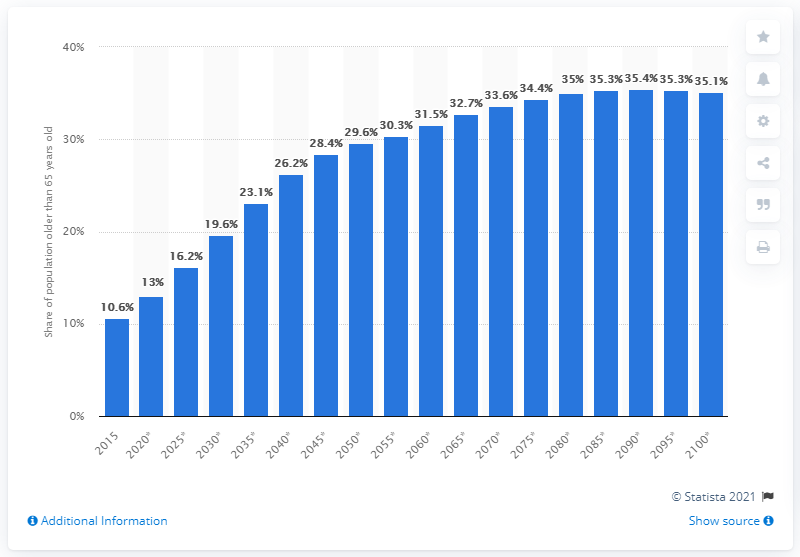Highlight a few significant elements in this photo. In 2015, approximately 10.6% of the population in Thailand was older than 65 years old. According to projections, by the year 2100, it is estimated that approximately 35.1% of Thailand's population will be over the age of 65. 